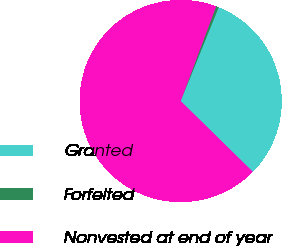Convert chart. <chart><loc_0><loc_0><loc_500><loc_500><pie_chart><fcel>Granted<fcel>Forfeited<fcel>Nonvested at end of year<nl><fcel>31.22%<fcel>0.42%<fcel>68.36%<nl></chart> 